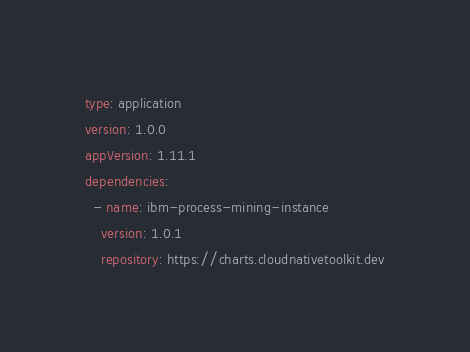<code> <loc_0><loc_0><loc_500><loc_500><_YAML_>type: application
version: 1.0.0
appVersion: 1.11.1
dependencies:
  - name: ibm-process-mining-instance
    version: 1.0.1
    repository: https://charts.cloudnativetoolkit.dev
</code> 